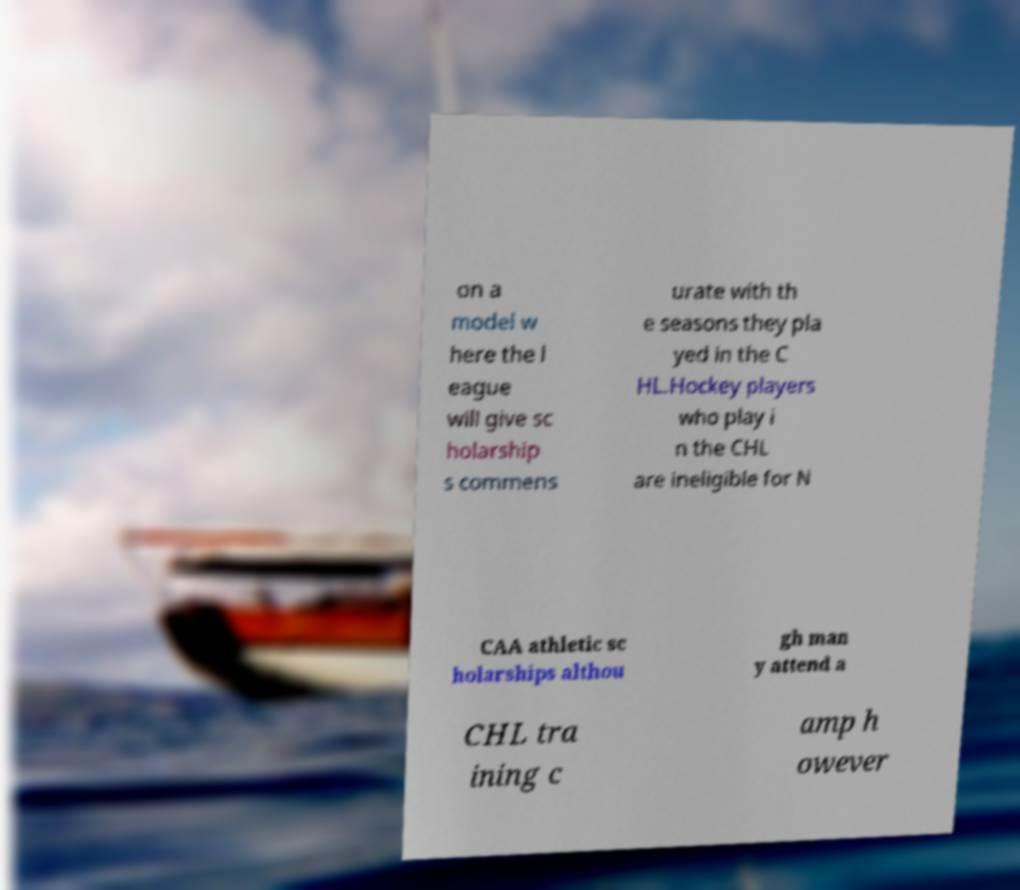Can you accurately transcribe the text from the provided image for me? on a model w here the l eague will give sc holarship s commens urate with th e seasons they pla yed in the C HL.Hockey players who play i n the CHL are ineligible for N CAA athletic sc holarships althou gh man y attend a CHL tra ining c amp h owever 